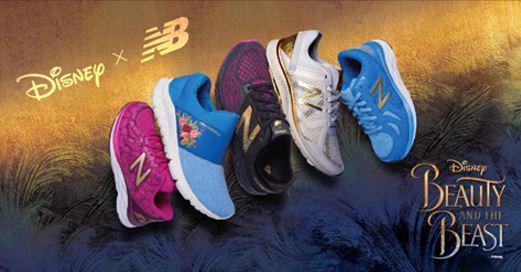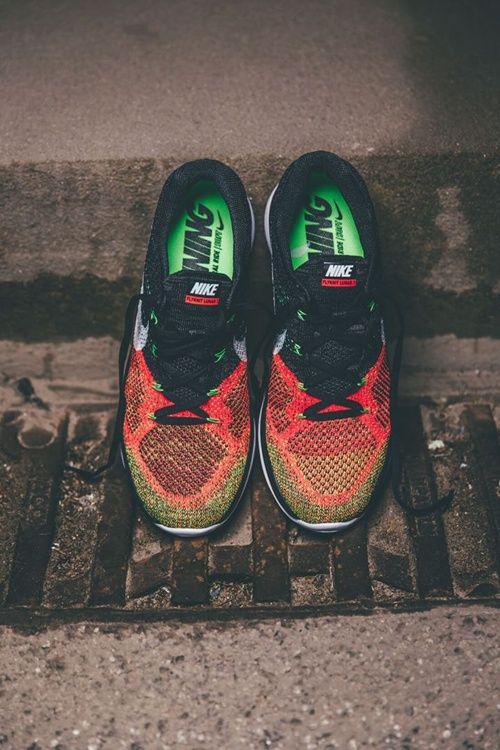The first image is the image on the left, the second image is the image on the right. Given the left and right images, does the statement "In total, no more than five individual shoes are shown." hold true? Answer yes or no. No. 